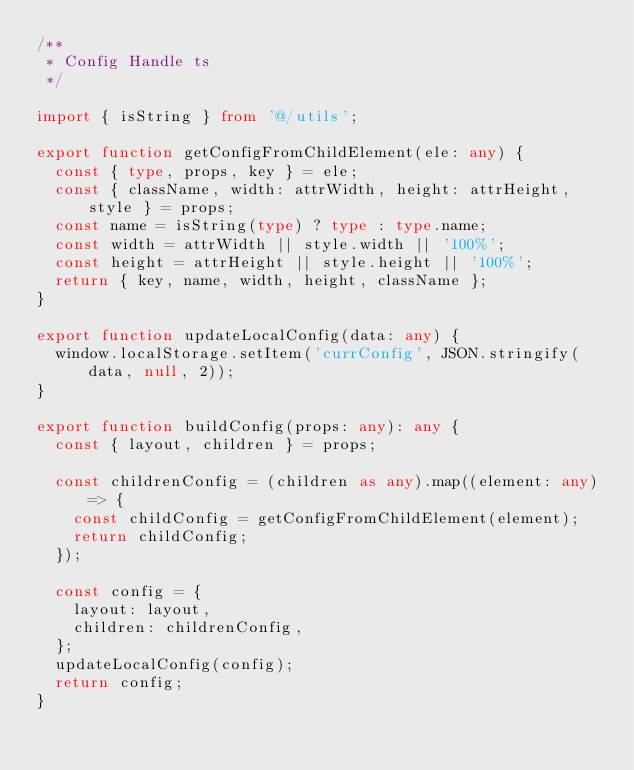Convert code to text. <code><loc_0><loc_0><loc_500><loc_500><_TypeScript_>/**
 * Config Handle ts
 */

import { isString } from '@/utils';

export function getConfigFromChildElement(ele: any) {
  const { type, props, key } = ele;
  const { className, width: attrWidth, height: attrHeight, style } = props;
  const name = isString(type) ? type : type.name;
  const width = attrWidth || style.width || '100%';
  const height = attrHeight || style.height || '100%';
  return { key, name, width, height, className };
}

export function updateLocalConfig(data: any) {
  window.localStorage.setItem('currConfig', JSON.stringify(data, null, 2));
}

export function buildConfig(props: any): any {
  const { layout, children } = props;

  const childrenConfig = (children as any).map((element: any) => {
    const childConfig = getConfigFromChildElement(element);
    return childConfig;
  });

  const config = {
    layout: layout,
    children: childrenConfig,
  };
  updateLocalConfig(config);
  return config;
}
</code> 